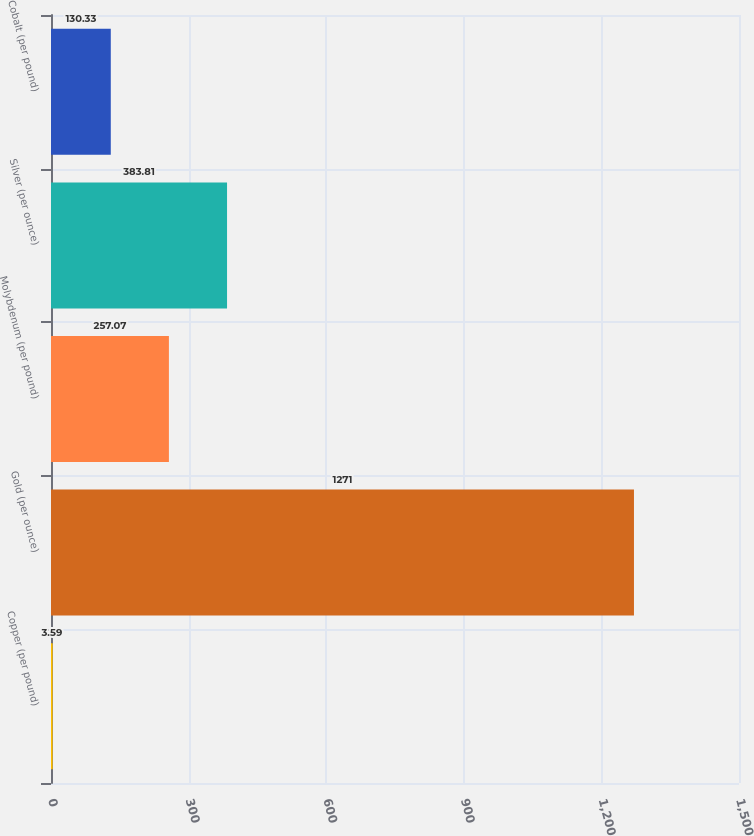Convert chart. <chart><loc_0><loc_0><loc_500><loc_500><bar_chart><fcel>Copper (per pound)<fcel>Gold (per ounce)<fcel>Molybdenum (per pound)<fcel>Silver (per ounce)<fcel>Cobalt (per pound)<nl><fcel>3.59<fcel>1271<fcel>257.07<fcel>383.81<fcel>130.33<nl></chart> 